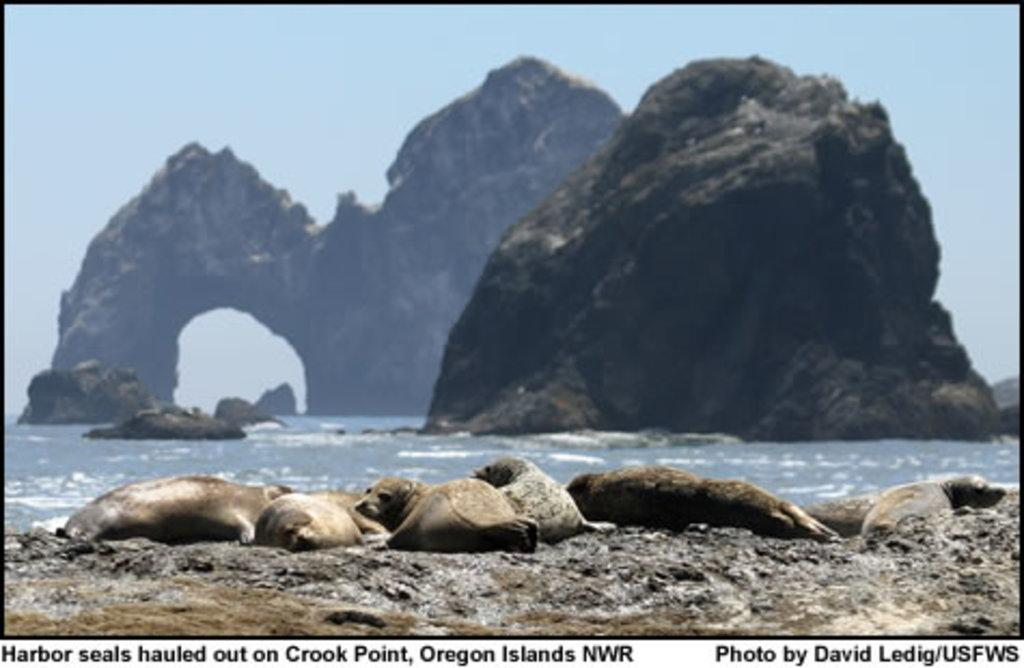What type of visual is the image? The image is a poster. What geographical features are depicted in the image? There are mountains in the image. What animals can be seen in the foreground of the image? There are seals in the foreground of the image. What part of the natural environment is visible at the top of the image? The sky is visible at the top of the image. What part of the natural environment is visible at the bottom of the image? There is water visible at the bottom of the image. What type of badge is the seal wearing in the image? There are no seals wearing badges in the image; the seals are in the foreground of the image, but no badges are visible. 